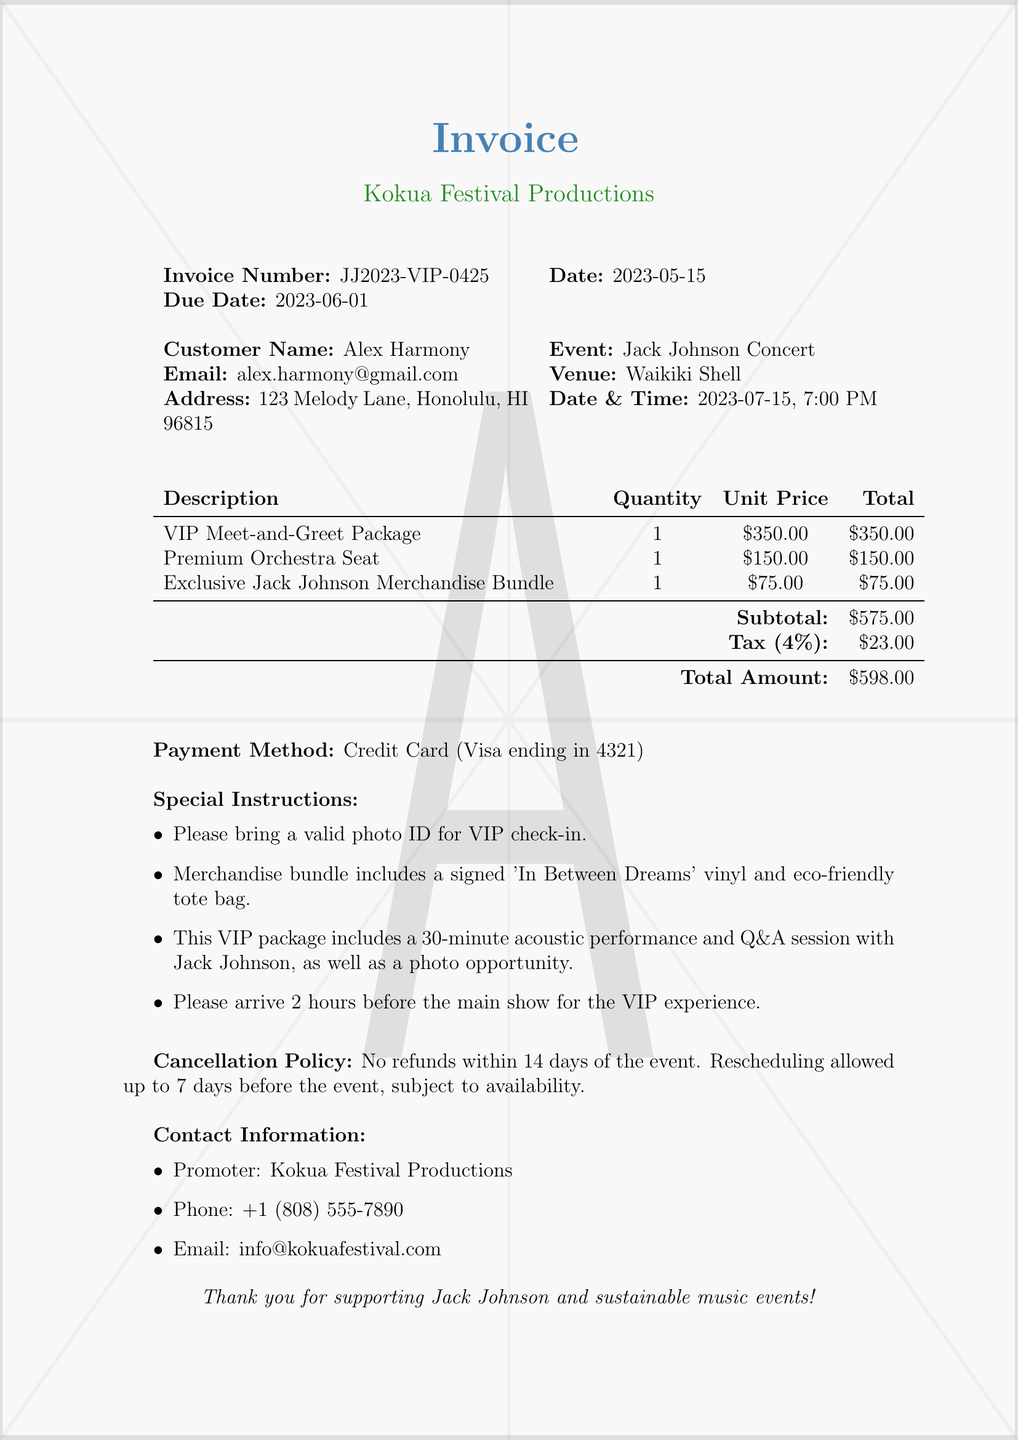What is the invoice number? The invoice number can be found in the document's header, specifically labeled as "Invoice Number."
Answer: JJ2023-VIP-0425 What is the due date? The due date is specified in the document under the "Due Date" section.
Answer: 2023-06-01 Who is the customer? The customer name is listed prominently in the document, specifically under the "Customer Name" section.
Answer: Alex Harmony What is the total amount due? The total amount is located in the invoice details, labeled as "Total Amount."
Answer: $598.00 What is included in the VIP Meet-and-Greet Package? This information is found in the "Special Instructions" section of the document, which details the features of the VIP package.
Answer: 30-minute acoustic performance and Q&A session with Jack Johnson How much tax is applied to the subtotal? The tax amount can be found in the invoice details, specifically labeled as "Tax."
Answer: $23.00 What is the cancellation policy? The cancellation policy is stated in a dedicated section within the document, summarizing the terms around refunds and rescheduling.
Answer: No refunds within 14 days of the event What is the event date and time? This information is highlighted in the event details section, under "Date & Time."
Answer: 2023-07-15, 7:00 PM What payment method was used? The payment method is specified towards the end of the invoice.
Answer: Credit Card (Visa ending in 4321) 